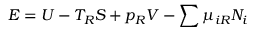Convert formula to latex. <formula><loc_0><loc_0><loc_500><loc_500>E = U - T _ { R } S + p _ { R } V - \sum \mu _ { i R } N _ { i }</formula> 